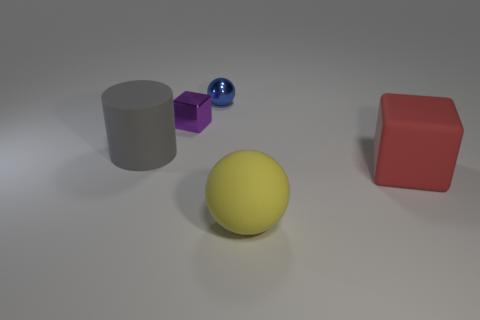Add 4 tiny brown spheres. How many objects exist? 9 Subtract all cylinders. How many objects are left? 4 Subtract all gray things. Subtract all tiny blue spheres. How many objects are left? 3 Add 2 gray cylinders. How many gray cylinders are left? 3 Add 1 rubber cylinders. How many rubber cylinders exist? 2 Subtract 0 yellow cubes. How many objects are left? 5 